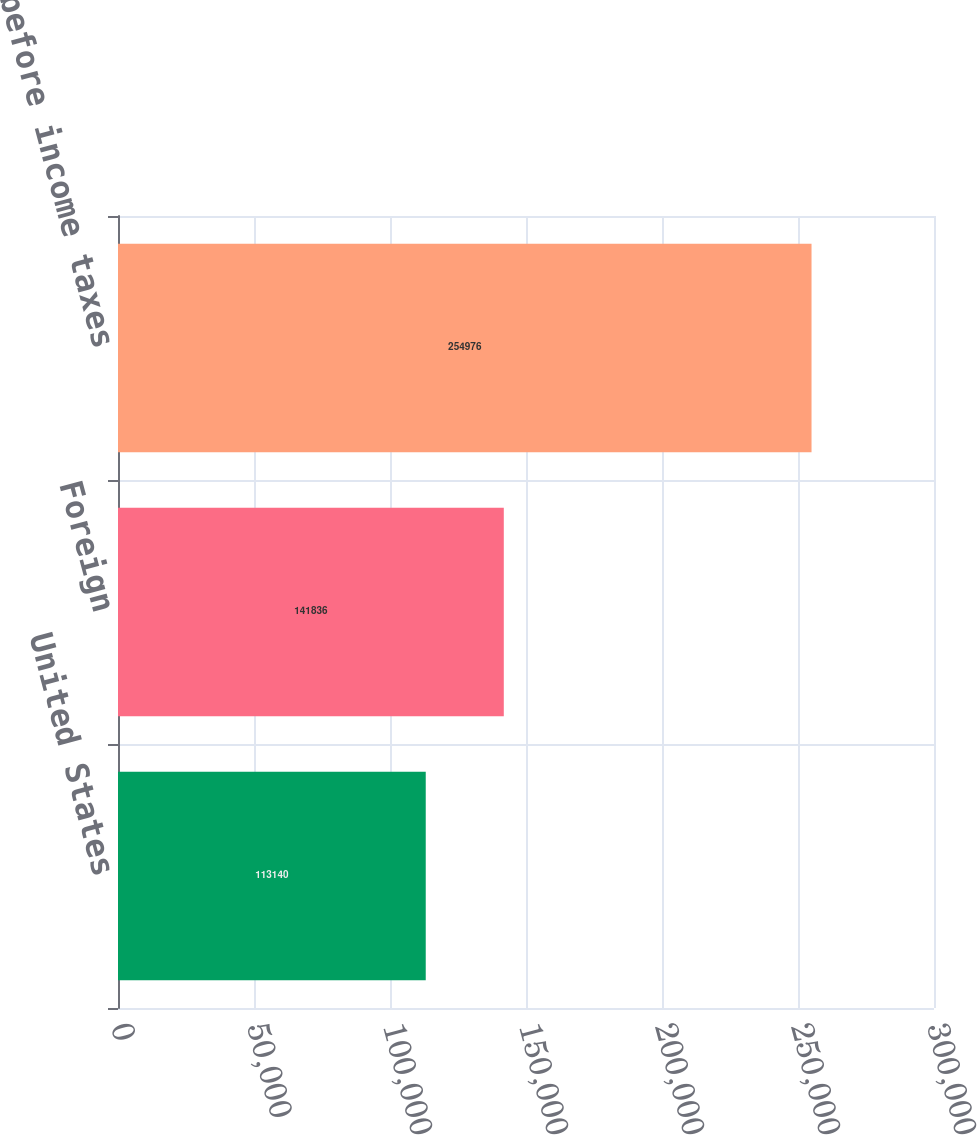Convert chart. <chart><loc_0><loc_0><loc_500><loc_500><bar_chart><fcel>United States<fcel>Foreign<fcel>Income before income taxes<nl><fcel>113140<fcel>141836<fcel>254976<nl></chart> 